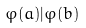<formula> <loc_0><loc_0><loc_500><loc_500>\varphi ( a ) | \varphi ( b )</formula> 